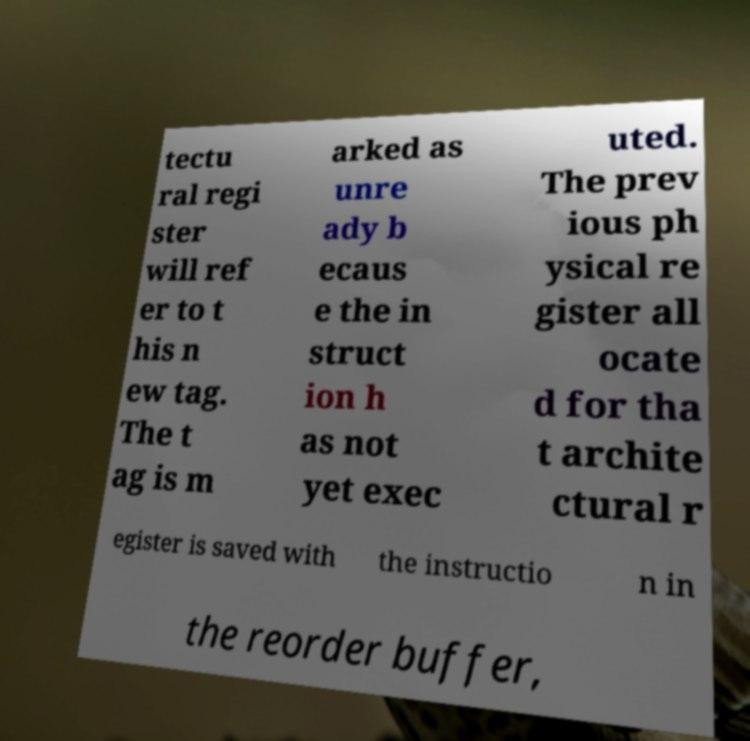Could you assist in decoding the text presented in this image and type it out clearly? tectu ral regi ster will ref er to t his n ew tag. The t ag is m arked as unre ady b ecaus e the in struct ion h as not yet exec uted. The prev ious ph ysical re gister all ocate d for tha t archite ctural r egister is saved with the instructio n in the reorder buffer, 